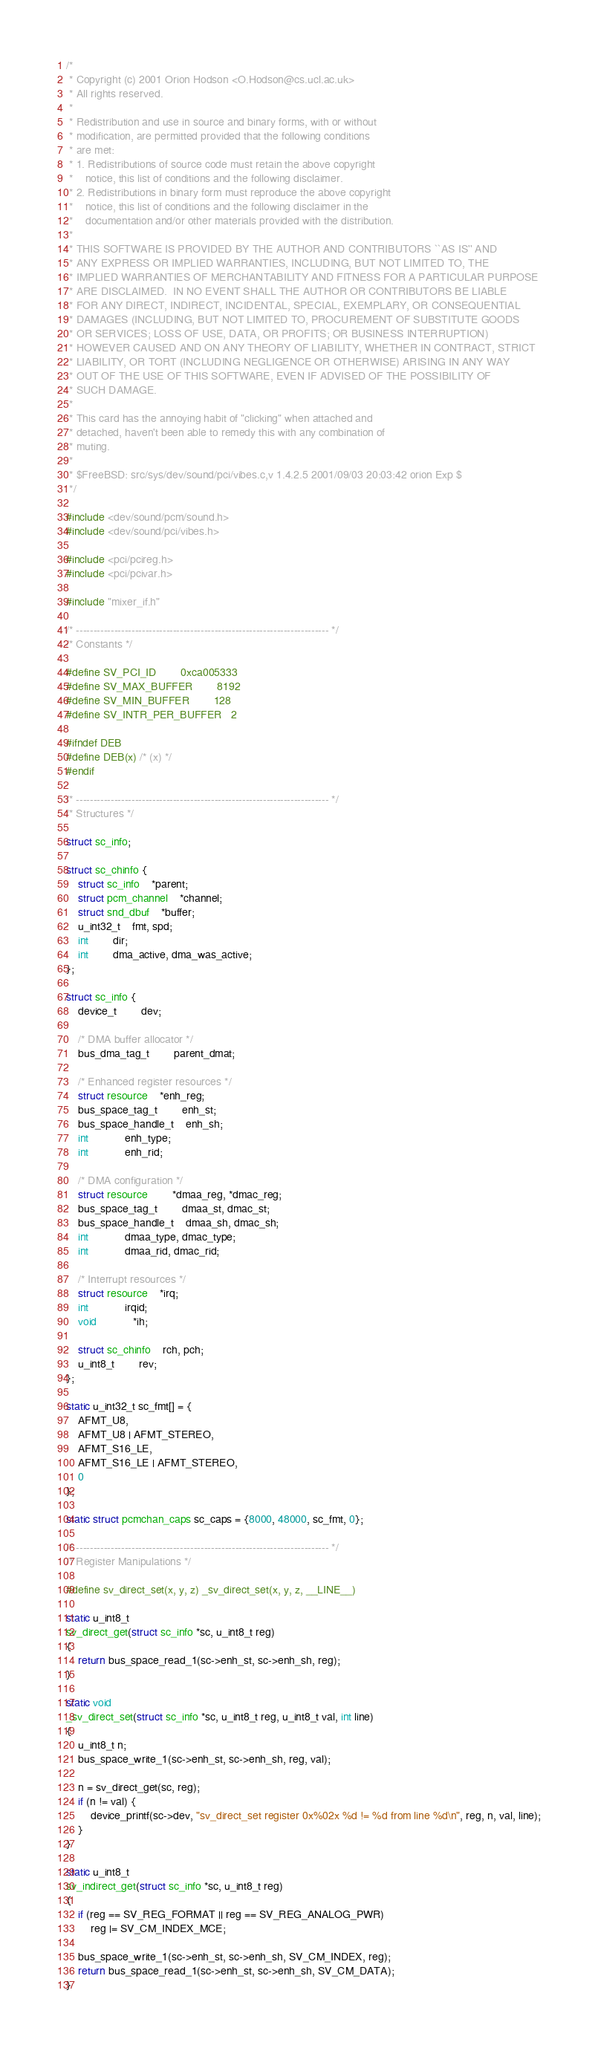<code> <loc_0><loc_0><loc_500><loc_500><_C_>/*
 * Copyright (c) 2001 Orion Hodson <O.Hodson@cs.ucl.ac.uk>
 * All rights reserved.
 *
 * Redistribution and use in source and binary forms, with or without
 * modification, are permitted provided that the following conditions
 * are met:
 * 1. Redistributions of source code must retain the above copyright
 *    notice, this list of conditions and the following disclaimer.
 * 2. Redistributions in binary form must reproduce the above copyright
 *    notice, this list of conditions and the following disclaimer in the
 *    documentation and/or other materials provided with the distribution.
 *
 * THIS SOFTWARE IS PROVIDED BY THE AUTHOR AND CONTRIBUTORS ``AS IS'' AND
 * ANY EXPRESS OR IMPLIED WARRANTIES, INCLUDING, BUT NOT LIMITED TO, THE
 * IMPLIED WARRANTIES OF MERCHANTABILITY AND FITNESS FOR A PARTICULAR PURPOSE
 * ARE DISCLAIMED.  IN NO EVENT SHALL THE AUTHOR OR CONTRIBUTORS BE LIABLE
 * FOR ANY DIRECT, INDIRECT, INCIDENTAL, SPECIAL, EXEMPLARY, OR CONSEQUENTIAL
 * DAMAGES (INCLUDING, BUT NOT LIMITED TO, PROCUREMENT OF SUBSTITUTE GOODS
 * OR SERVICES; LOSS OF USE, DATA, OR PROFITS; OR BUSINESS INTERRUPTION)
 * HOWEVER CAUSED AND ON ANY THEORY OF LIABILITY, WHETHER IN CONTRACT, STRICT
 * LIABILITY, OR TORT (INCLUDING NEGLIGENCE OR OTHERWISE) ARISING IN ANY WAY
 * OUT OF THE USE OF THIS SOFTWARE, EVEN IF ADVISED OF THE POSSIBILITY OF
 * SUCH DAMAGE.
 *
 * This card has the annoying habit of "clicking" when attached and
 * detached, haven't been able to remedy this with any combination of
 * muting.
 *
 * $FreeBSD: src/sys/dev/sound/pci/vibes.c,v 1.4.2.5 2001/09/03 20:03:42 orion Exp $
 */

#include <dev/sound/pcm/sound.h>
#include <dev/sound/pci/vibes.h>

#include <pci/pcireg.h>
#include <pci/pcivar.h>

#include "mixer_if.h"

/* ------------------------------------------------------------------------- */
/* Constants */

#define SV_PCI_ID		0xca005333
#define SV_MAX_BUFFER		8192
#define SV_MIN_BUFFER		128
#define SV_INTR_PER_BUFFER	2

#ifndef DEB
#define DEB(x) /* (x) */
#endif

/* ------------------------------------------------------------------------- */
/* Structures */

struct sc_info;

struct sc_chinfo {
	struct sc_info	*parent;
	struct pcm_channel	*channel;
	struct snd_dbuf	*buffer;
	u_int32_t	fmt, spd;
	int		dir;
	int		dma_active, dma_was_active;
};

struct sc_info {
	device_t		dev;

	/* DMA buffer allocator */
	bus_dma_tag_t		parent_dmat;

	/* Enhanced register resources */
	struct resource 	*enh_reg;
	bus_space_tag_t		enh_st;
	bus_space_handle_t	enh_sh;
	int			enh_type;
	int			enh_rid;

	/* DMA configuration */
	struct resource		*dmaa_reg, *dmac_reg;
	bus_space_tag_t		dmaa_st, dmac_st;
	bus_space_handle_t	dmaa_sh, dmac_sh;
	int			dmaa_type, dmac_type;
	int			dmaa_rid, dmac_rid;

	/* Interrupt resources */
	struct resource 	*irq;
	int			irqid;
	void			*ih;

	struct sc_chinfo	rch, pch;
	u_int8_t		rev;
};

static u_int32_t sc_fmt[] = {
	AFMT_U8,
	AFMT_U8 | AFMT_STEREO,
	AFMT_S16_LE,
	AFMT_S16_LE | AFMT_STEREO,
	0
};

static struct pcmchan_caps sc_caps = {8000, 48000, sc_fmt, 0};

/* ------------------------------------------------------------------------- */
/* Register Manipulations */

#define sv_direct_set(x, y, z) _sv_direct_set(x, y, z, __LINE__)

static u_int8_t
sv_direct_get(struct sc_info *sc, u_int8_t reg)
{
	return bus_space_read_1(sc->enh_st, sc->enh_sh, reg);
}

static void
_sv_direct_set(struct sc_info *sc, u_int8_t reg, u_int8_t val, int line)
{
	u_int8_t n;
	bus_space_write_1(sc->enh_st, sc->enh_sh, reg, val);

	n = sv_direct_get(sc, reg);
	if (n != val) {
		device_printf(sc->dev, "sv_direct_set register 0x%02x %d != %d from line %d\n", reg, n, val, line);
	}
}

static u_int8_t
sv_indirect_get(struct sc_info *sc, u_int8_t reg)
{
	if (reg == SV_REG_FORMAT || reg == SV_REG_ANALOG_PWR)
		reg |= SV_CM_INDEX_MCE;

	bus_space_write_1(sc->enh_st, sc->enh_sh, SV_CM_INDEX, reg);
	return bus_space_read_1(sc->enh_st, sc->enh_sh, SV_CM_DATA);
}
</code> 